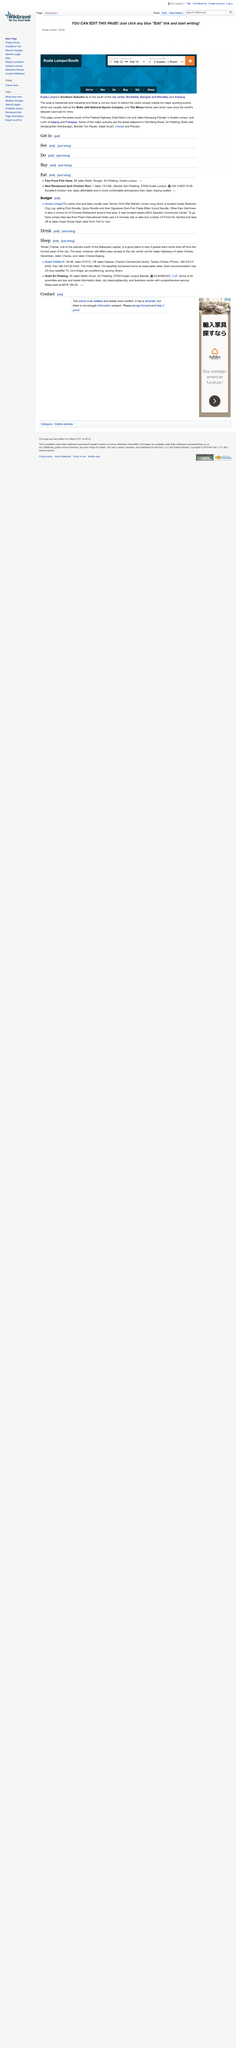Mention a couple of crucial points in this snapshot. Uncle Liong is located inside Restoran Ong Lay. At Uncle Liong, a variety of delectable noodle dishes are available, including mouthwatering pork noodles, spicy options, and their renowned fish paste bitter gourd noodle. If you are looking for a place to stay, Taman Cheras is a good place to consider. 